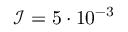Convert formula to latex. <formula><loc_0><loc_0><loc_500><loc_500>\mathcal { I } = 5 \cdot 1 0 ^ { - 3 }</formula> 